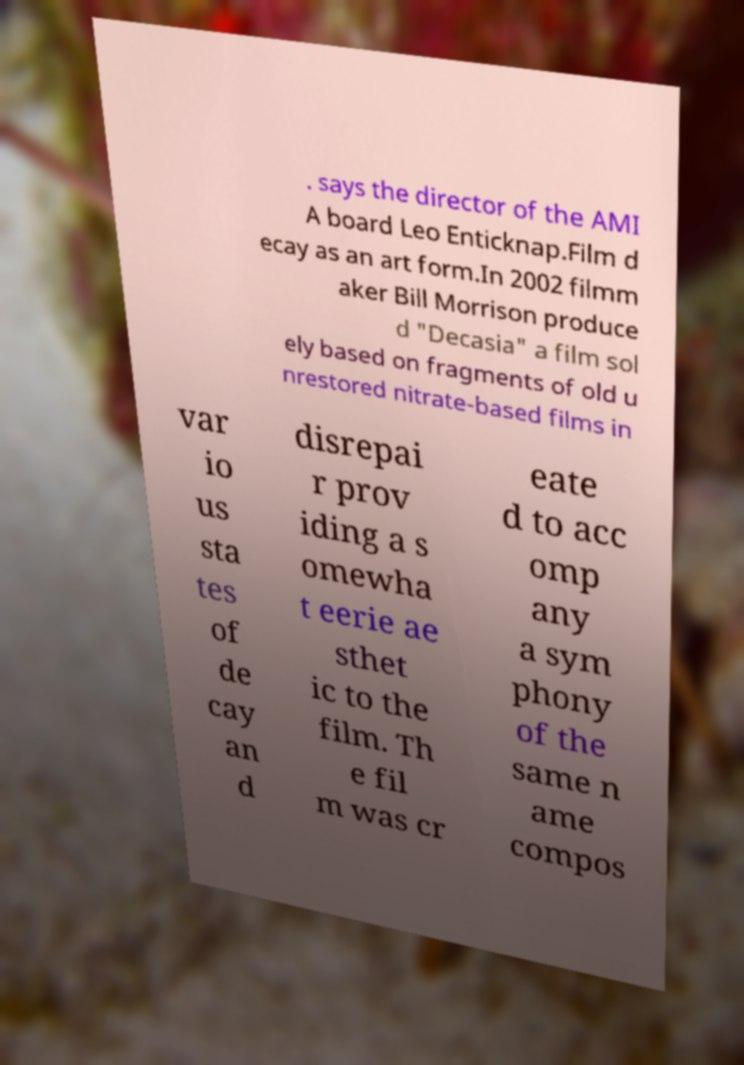I need the written content from this picture converted into text. Can you do that? . says the director of the AMI A board Leo Enticknap.Film d ecay as an art form.In 2002 filmm aker Bill Morrison produce d "Decasia" a film sol ely based on fragments of old u nrestored nitrate-based films in var io us sta tes of de cay an d disrepai r prov iding a s omewha t eerie ae sthet ic to the film. Th e fil m was cr eate d to acc omp any a sym phony of the same n ame compos 